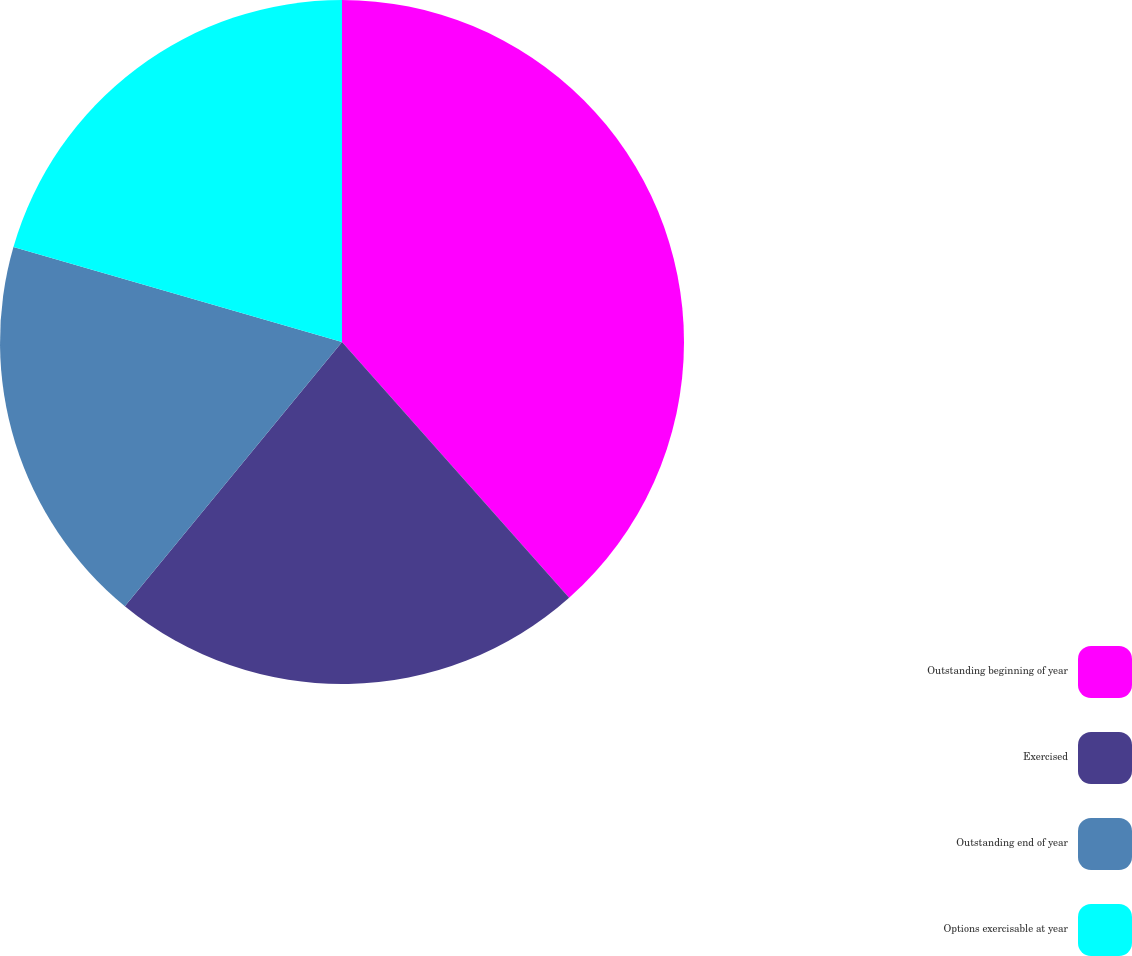<chart> <loc_0><loc_0><loc_500><loc_500><pie_chart><fcel>Outstanding beginning of year<fcel>Exercised<fcel>Outstanding end of year<fcel>Options exercisable at year<nl><fcel>38.44%<fcel>22.51%<fcel>18.53%<fcel>20.52%<nl></chart> 